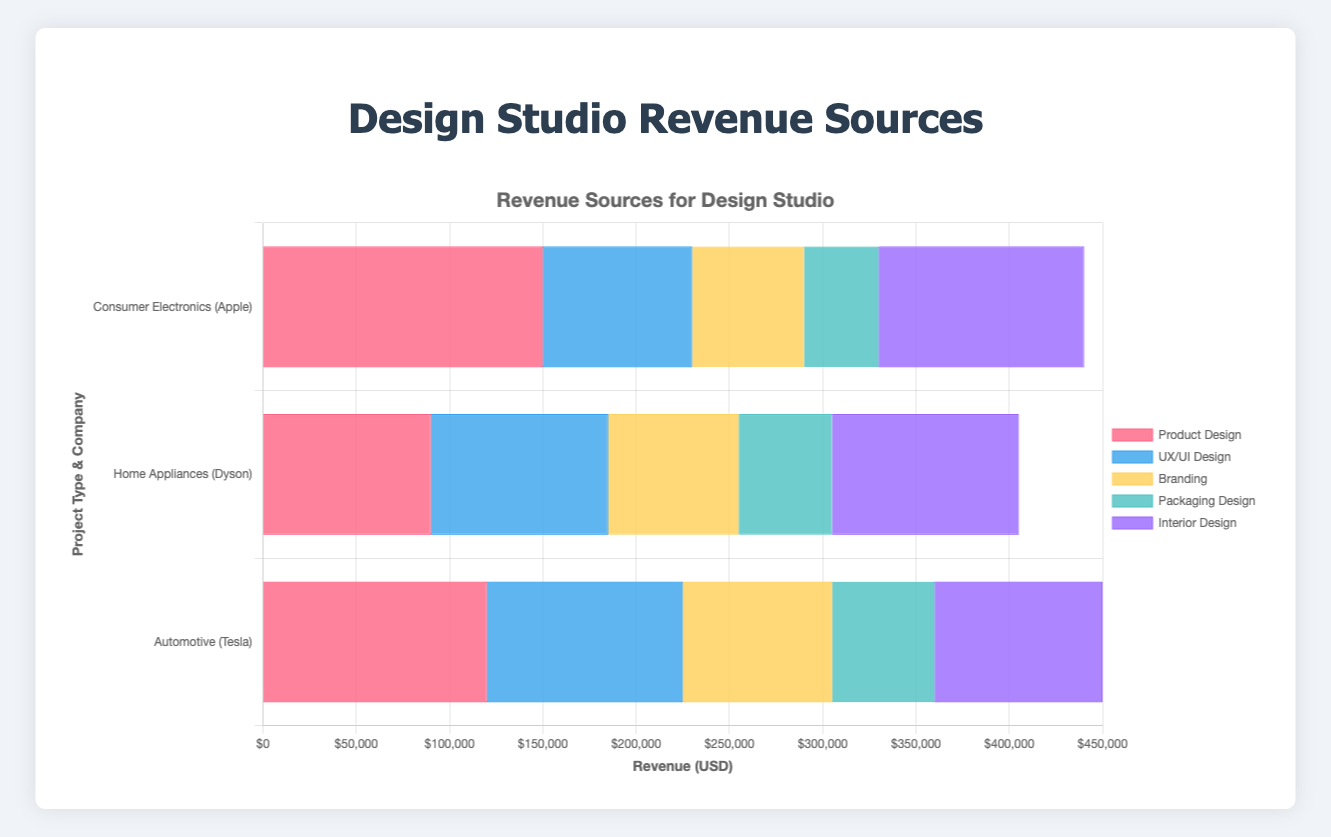What is the total revenue for Product Design projects? The total revenue for Product Design projects can be found by summing up the revenues from Consumer Electronics, Home Appliances, and Automotive. That is, $150,000 (Apple) + $90,000 (Dyson) + $120,000 (Tesla) = $360,000.
Answer: $360,000 Which project type had the highest single revenue amount, and what was it? Reviewing the highest single revenue across all project types, we find that Product Design (Consumer Electronics by Apple) had the highest single revenue amount of $150,000.
Answer: Product Design ($150,000) Which company contributed the most revenue to the Interior Design projects? By comparing the revenues from retail spaces (IKEA), corporate offices (Google), and hospitality (Marriott), we see that IKEA contributed the highest amount at $110,000.
Answer: IKEA Compare the total revenue from Branding and UX/UI Design projects. Which is higher? The total revenue for Branding is $60,000 (Slack) + $70,000 (Procter & Gamble) + $80,000 (Goldman Sachs) = $210,000. For UX/UI Design, it is $80,000 (Google) + $95,000 (Amazon) + $105,000 (Microsoft) = $280,000. Comparing both, UX/UI Design has the higher total revenue.
Answer: UX/UI Design What is the average revenue per project type for Packaging Design projects? Summing up the revenues of Packaging Design from beverages (Coca-Cola), cosmetics (L'Oréal), and food products (Nestlé) gives $40,000 + $50,000 + $55,000 = $145,000. Dividing by the number of projects (3) gives an average revenue of $145,000/3 = $48,333.33.
Answer: $48,333.33 How does the revenue from Corporate Offices (Interior Design) compare to Enterprise Software (UX/UI Design)? The revenue from Corporate Offices (Interior Design by Google) is $100,000, and the revenue from Enterprise Software (UX/UI Design by Microsoft) is $105,000. The revenue from Enterprise Software is $5,000 higher.
Answer: Enterprise Software is $5,000 higher Identify the project type which received the lowest total revenue. Summing up the total revenues for each project type, Packaging Design: $145,000; Branding: $210,000; Interior Design: $300,000; Product Design: $360,000; UX/UI Design: $280,000. Packaging Design received the lowest total revenue of $145,000.
Answer: Packaging Design Which project type and company combination produced the lowest single revenue amount, and what was it? The lowest single revenue amount from all combinations is $40,000 from Packaging Design (Beverages by Coca-Cola).
Answer: Packaging Design (Coca-Cola) $40,000 How much more revenue did Tesla generate from Automotive projects compared to Dyson from Home Appliances projects? The revenue from Tesla for Automotive is $120,000, and from Dyson for Home Appliances is $90,000. The difference is $120,000 - $90,000 = $30,000. Tesla generated $30,000 more revenue than Dyson.
Answer: $30,000 